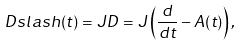<formula> <loc_0><loc_0><loc_500><loc_500>\ D s l a s h ( t ) = J D = J \left ( \frac { d } { d t } - A ( t ) \right ) ,</formula> 